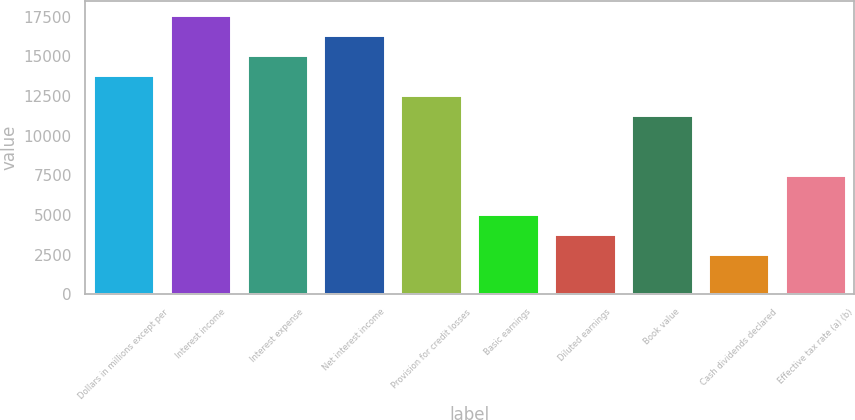Convert chart. <chart><loc_0><loc_0><loc_500><loc_500><bar_chart><fcel>Dollars in millions except per<fcel>Interest income<fcel>Interest expense<fcel>Net interest income<fcel>Provision for credit losses<fcel>Basic earnings<fcel>Diluted earnings<fcel>Book value<fcel>Cash dividends declared<fcel>Effective tax rate (a) (b)<nl><fcel>13840.1<fcel>17614.2<fcel>15098.1<fcel>16356.2<fcel>12582<fcel>5033.65<fcel>3775.59<fcel>11324<fcel>2517.53<fcel>7549.77<nl></chart> 